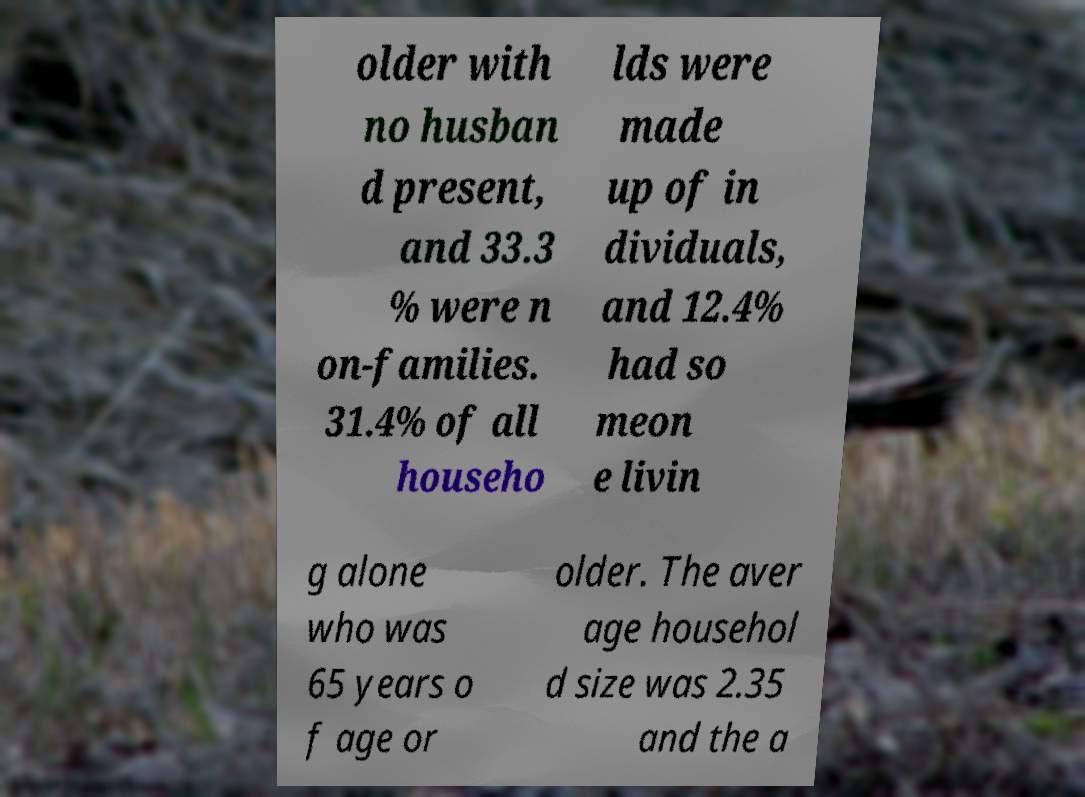Could you extract and type out the text from this image? older with no husban d present, and 33.3 % were n on-families. 31.4% of all househo lds were made up of in dividuals, and 12.4% had so meon e livin g alone who was 65 years o f age or older. The aver age househol d size was 2.35 and the a 